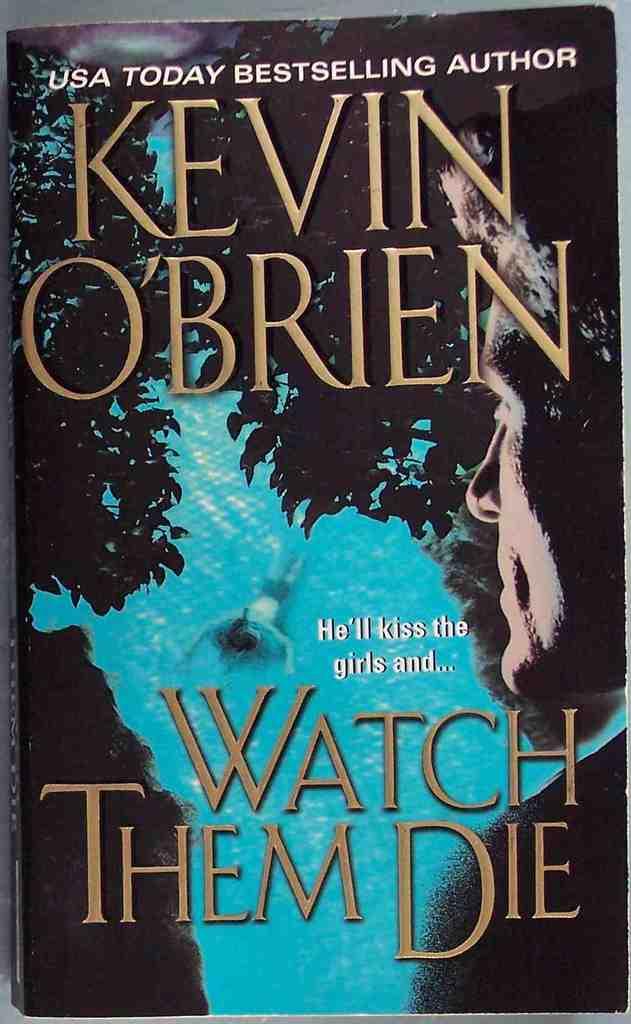What's the title of the book?
Offer a terse response. Watch them die. 